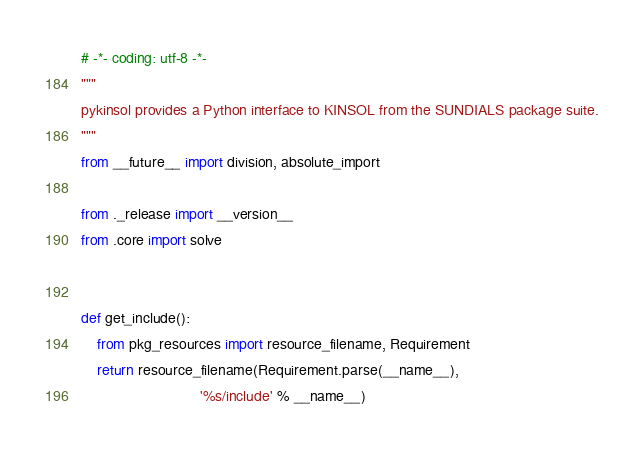Convert code to text. <code><loc_0><loc_0><loc_500><loc_500><_Python_># -*- coding: utf-8 -*-
"""
pykinsol provides a Python interface to KINSOL from the SUNDIALS package suite.
"""
from __future__ import division, absolute_import

from ._release import __version__
from .core import solve


def get_include():
    from pkg_resources import resource_filename, Requirement
    return resource_filename(Requirement.parse(__name__),
                             '%s/include' % __name__)
</code> 